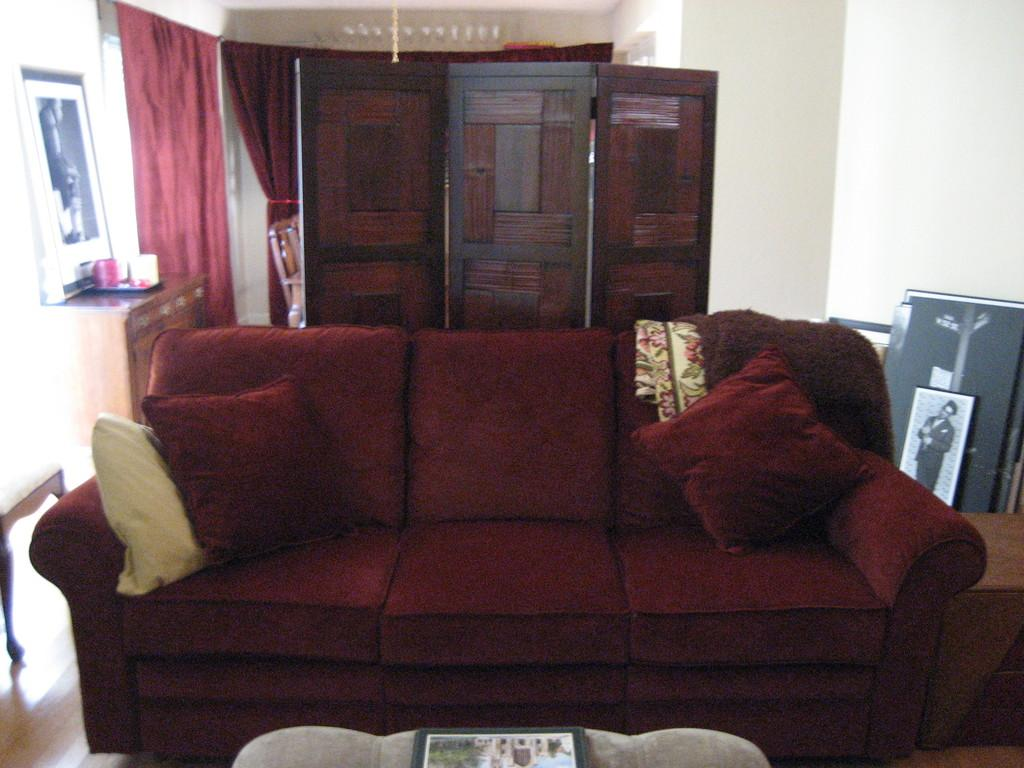What type of furniture is in the image? There is a sofa in the image. What is placed on the sofa? Pillows are placed on the sofa. What can be seen in the background of the image? There are wooden walls, curtains, and photo frames in the background of the image. How many walls are visible in the image? There is one wall visible in the image. What type of rice is being cooked in the image? There is no rice present in the image; it features a sofa with pillows and a background with wooden walls, curtains, and photo frames. 